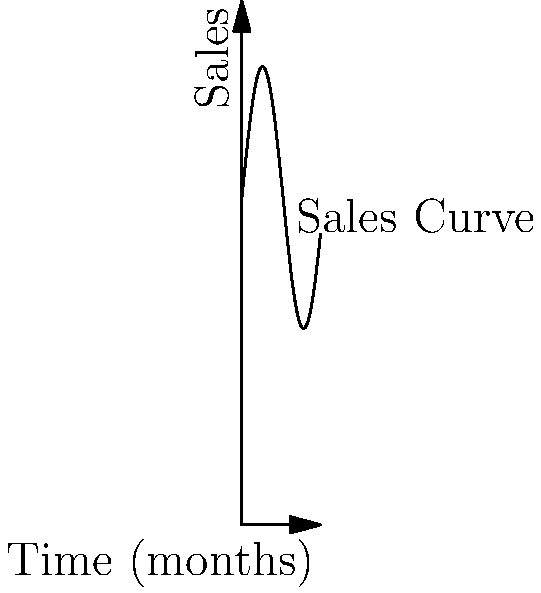The graph represents the sales of a rare Eastern European novel over a 12-month period. If the sales function is given by $S(t) = 50 + 20\sin(\frac{t}{2})$, where $S$ is the number of books sold and $t$ is the time in months, at what point(s) in time is the rate of change of sales equal to zero? To find the point(s) where the rate of change of sales is zero, we need to follow these steps:

1) The rate of change of sales is represented by the derivative of the sales function $S(t)$.

2) Let's calculate the derivative:
   $S'(t) = \frac{d}{dt}[50 + 20\sin(\frac{t}{2})]$
   $S'(t) = 20 \cdot \frac{1}{2} \cos(\frac{t}{2}) = 10\cos(\frac{t}{2})$

3) The rate of change is zero when $S'(t) = 0$:
   $10\cos(\frac{t}{2}) = 0$

4) Solving this equation:
   $\cos(\frac{t}{2}) = 0$
   $\frac{t}{2} = \frac{\pi}{2} + \pi n$, where $n$ is any integer

5) Solving for $t$:
   $t = \pi + 2\pi n$

6) Within the given 12-month period (0 ≤ t ≤ 12), this equation is satisfied when:
   $t = \pi \approx 3.14$ months
   $t = 3\pi \approx 9.42$ months

Therefore, the rate of change of sales is zero at approximately 3.14 and 9.42 months.
Answer: 3.14 and 9.42 months 